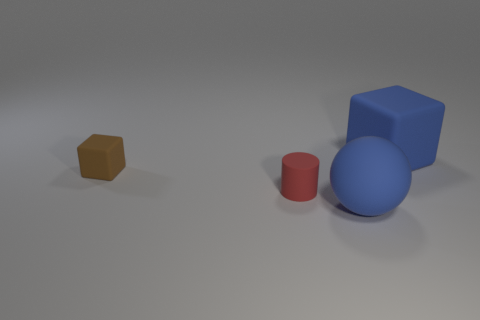What is the shape of the large rubber thing that is in front of the small thing in front of the brown object?
Provide a succinct answer. Sphere. Are there fewer large red rubber blocks than blue rubber balls?
Your response must be concise. Yes. Do the blue ball and the big block have the same material?
Your answer should be very brief. Yes. What is the color of the thing that is both behind the tiny red rubber cylinder and left of the big blue cube?
Offer a very short reply. Brown. Is there a object that has the same size as the blue cube?
Your answer should be compact. Yes. There is a cube to the left of the small object that is right of the tiny brown matte thing; what is its size?
Provide a succinct answer. Small. Are there fewer cylinders that are to the right of the big matte sphere than blue matte things?
Provide a succinct answer. Yes. Is the matte cylinder the same color as the small block?
Make the answer very short. No. The brown rubber block is what size?
Offer a terse response. Small. How many big balls are the same color as the tiny block?
Your answer should be compact. 0. 